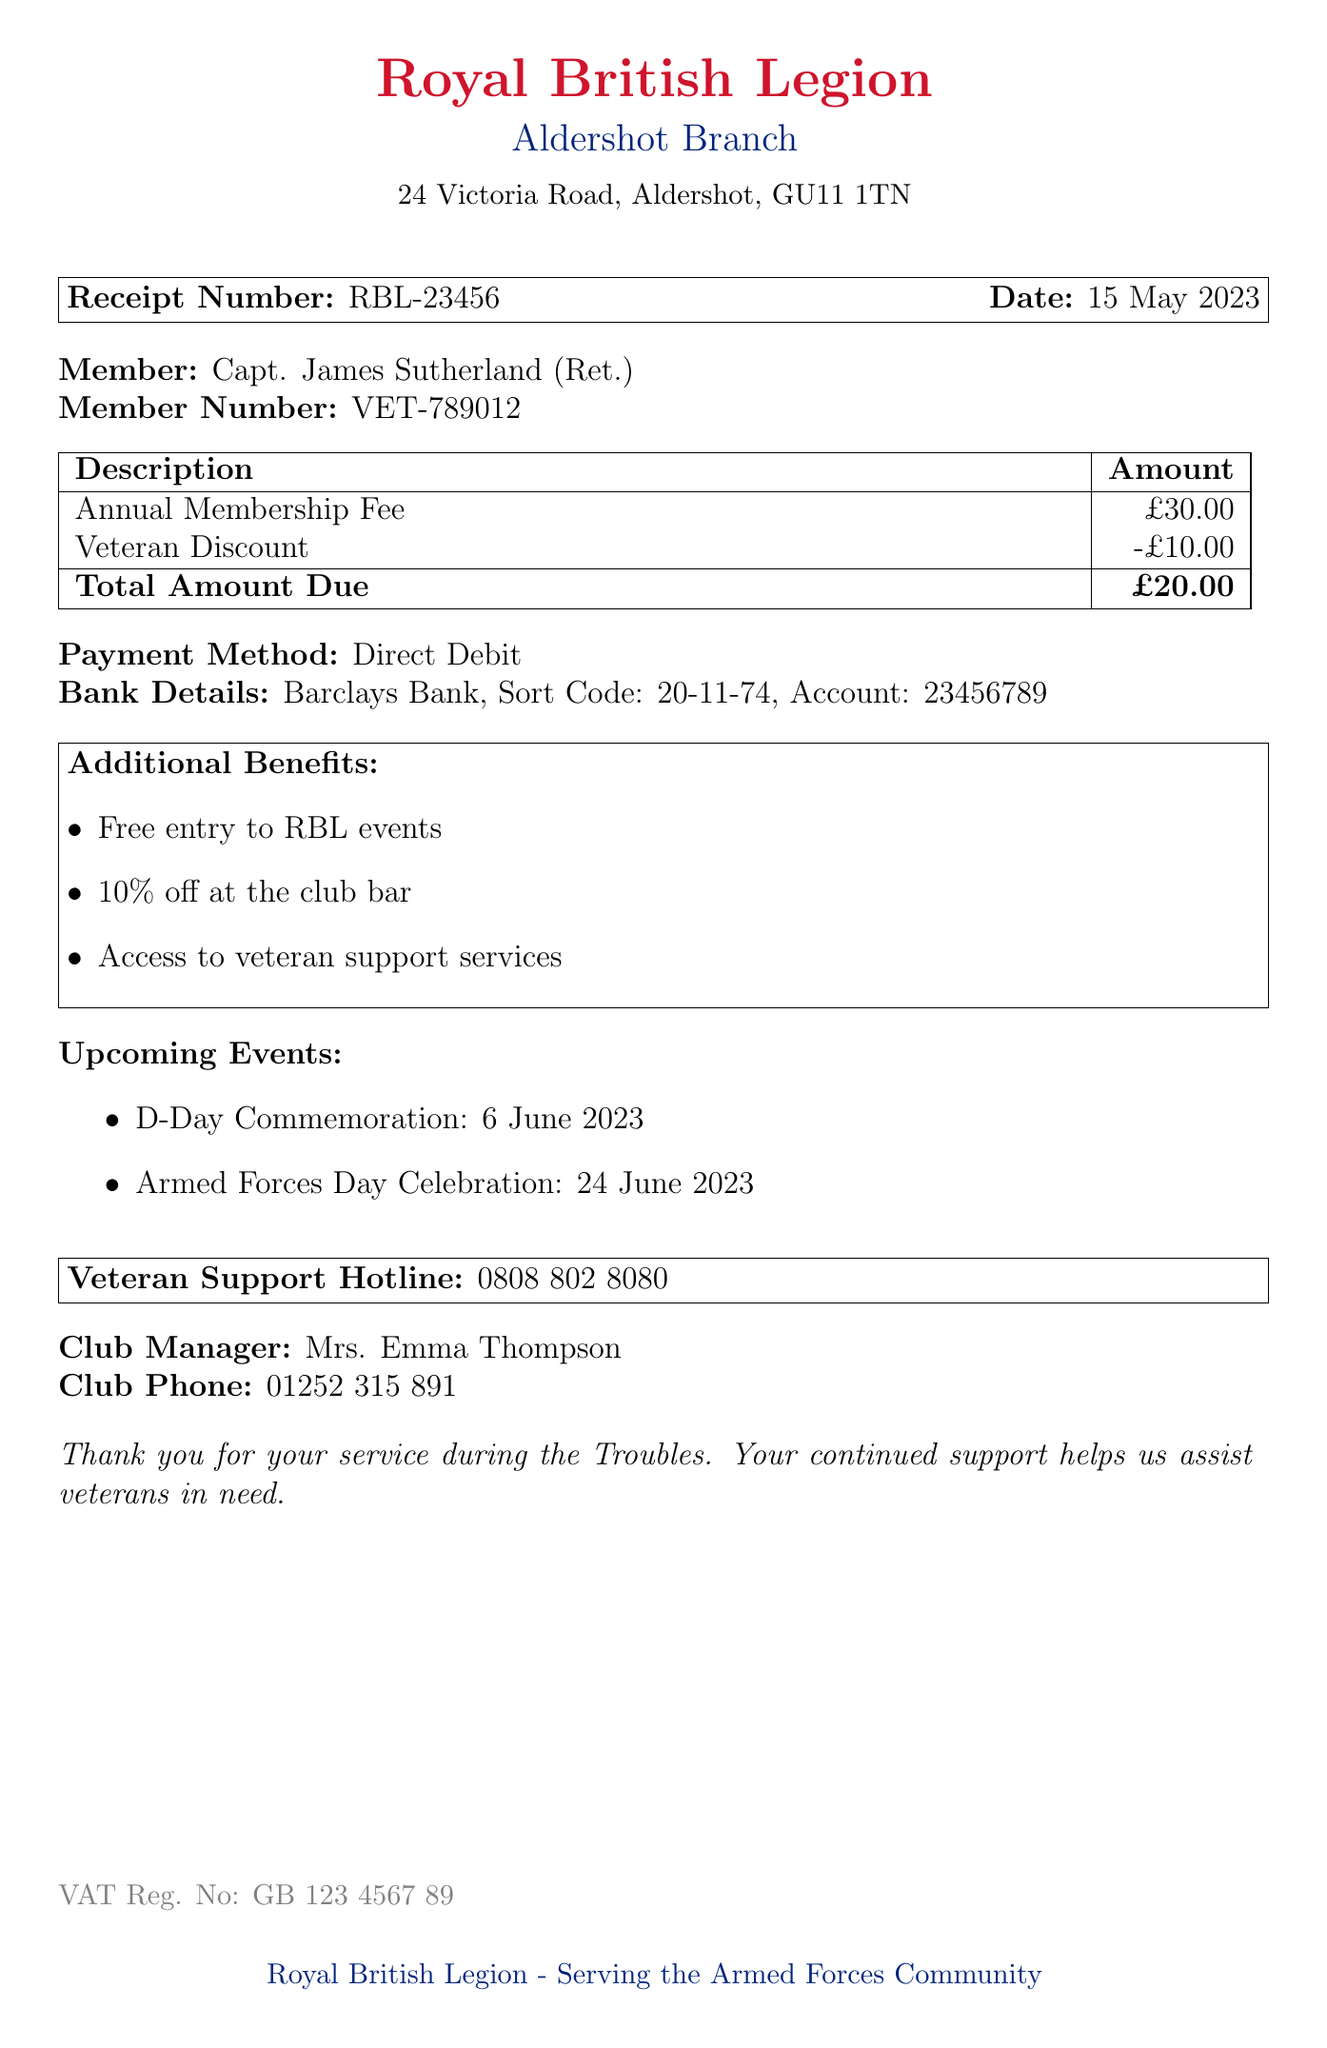What is the receipt number? The receipt number is explicitly stated in the document and identifies the receipt uniquely.
Answer: RBL-23456 What is the date of the receipt? The date of the receipt is provided in the document, indicating when the transaction occurred.
Answer: 15 May 2023 What is the annual membership fee? The annual membership fee is listed in the document under the charges section.
Answer: £30.00 What is the total amount due after the veteran discount? The total amount due is calculated after applying the veteran discount, which is mentioned in the document.
Answer: £20.00 What is the veteran discount amount? The amount deducted for the veteran discount is specified in the document.
Answer: £10.00 Who is the club manager? The name of the club manager is mentioned explicitly in the document.
Answer: Mrs. Emma Thompson What payment method was used? The document states how the payment was processed.
Answer: Direct Debit What is one benefit of membership? The document lists several benefits; one of these benefits is queried here.
Answer: Free entry to RBL events How can veterans get support? The document provides a hotline number specifically for veteran support.
Answer: 0808 802 8080 When is the D-Day Commemoration event? The upcoming events are listed in the document, including dates for specific events.
Answer: 6 June 2023 